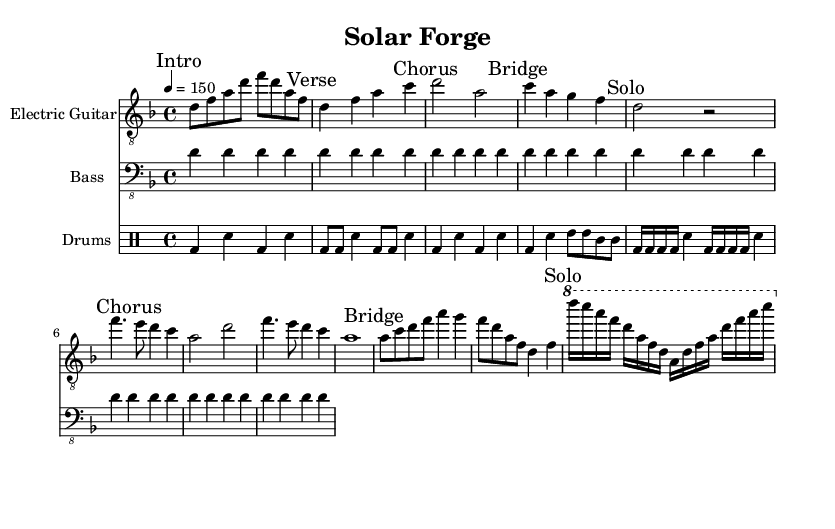What is the key signature of this music? The key signature is indicated at the beginning of the staff and shows two flat notes, B-flat and E-flat, which together represent the key of D minor.
Answer: D minor What is the time signature? The time signature is shown at the beginning of the music and indicates the rhythm structure, which is four beats per measure, represented by the 4/4 notation.
Answer: 4/4 What is the tempo marking for this piece? The tempo marking, written as a quarter note equals 150, indicates how fast the music should be played, allowing us to see that it has a brisk pace.
Answer: 150 How many measures are in the "Chorus" section? The "Chorus" section is marked and contains four measures, identifiable by counting the measures indicated in that section.
Answer: 4 Which instrument plays the solo section? The "Solo" section is marked specifically for the electric guitar, noted by the appropriate instrument on its line and the description of the solo that follows.
Answer: Electric Guitar What rhythmic pattern does the drums follow during the "Verse"? In the "Verse", the drums use a combination of bass and snare hits in a consistent repeating pattern that can be analyzed by looking at the drum notes only in that section.
Answer: Bass and Snare 